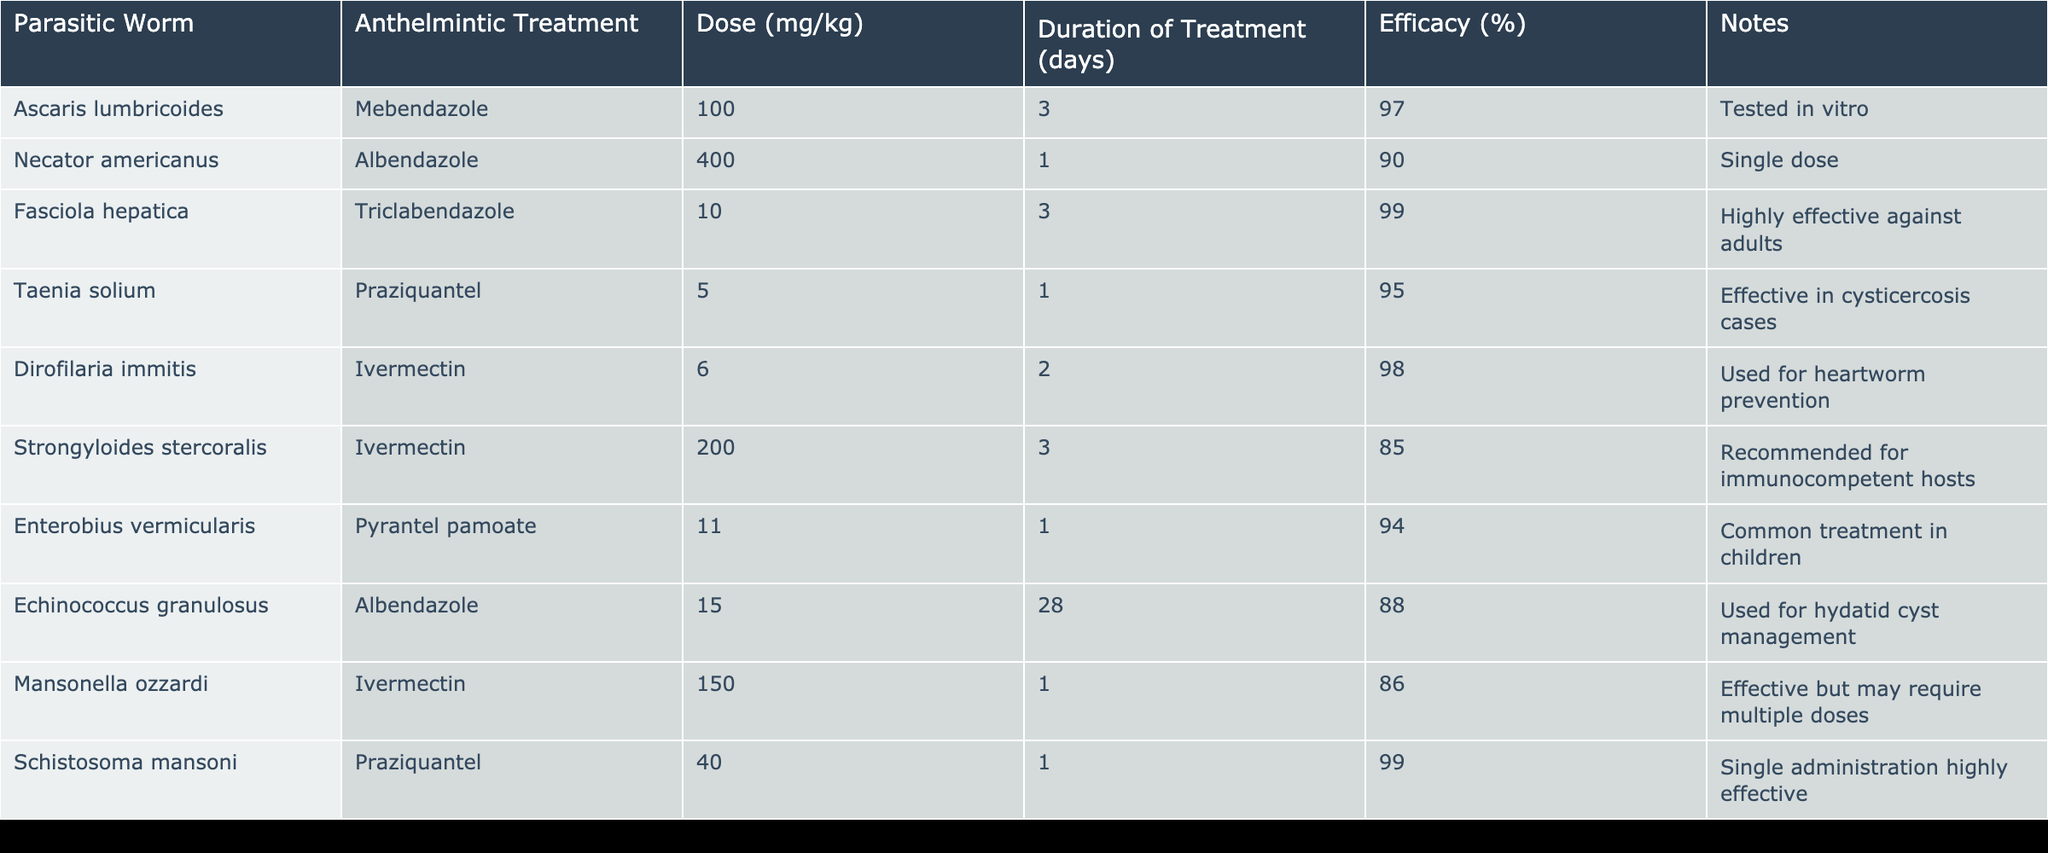What is the efficacy of Mebendazole in treating Ascaris lumbricoides? The table lists the efficacy of Mebendazole for Ascaris lumbricoides as 97%. This information is directly taken from the corresponding row in the table.
Answer: 97% Which anthelmintic treatment has the highest efficacy? Looking through the efficacy percentages in the table, Triclabendazole for Fasciola hepatica shows the highest value at 99%. Thus, it can be concluded that this treatment is the most effective among those listed.
Answer: 99% How many days was Ivermectin administered to treat Strongyloides stercoralis? The table indicates that Ivermectin was administered for 3 days to treat Strongyloides stercoralis, as found in the relevant row under the Duration of Treatment column.
Answer: 3 days Is Pyrantel pamoate effective against Enterobius vermicularis? According to the table, Pyrantel pamoate has an efficacy of 94%, which indicates that it is effective against Enterobius vermicularis.
Answer: Yes What is the average efficacy of the anthelmintic treatments listed in the table? First, I need to sum the efficacy percentages of all treatments: 97 + 90 + 99 + 95 + 98 + 85 + 94 + 88 + 86 + 99 = 921. There are 10 treatments, so the average efficacy is 921 ÷ 10 = 92.1%.
Answer: 92.1% Which two treatments have an efficacy of at least 95%? By examining the efficacy column, I note that Mebendazole (97%) and Triclabendazole (99%) both meet the criterion of having at least 95% efficacy. Therefore, those two treatments are the answer to the question.
Answer: Mebendazole and Triclabendazole What is the dose of Albendazole used for treating Echinococcus granulosus? The table shows that the dose of Albendazole for Echinococcus granulosus is 15 mg/kg, as found in the respective entry in the Dose column.
Answer: 15 mg/kg Is there any treatment that has a duration of 1 day? Yes, the table indicates that both Albendazole (for Necator americanus) and Praziquantel (for Schistosoma mansoni) have a duration of treatment of 1 day, confirming that treatments with this duration do exist in the provided data.
Answer: Yes Which treatment is used for heartworm prevention? The table specifies that Ivermectin, with a dose of 6 mg/kg, is used for heartworm prevention. This information can be directly located under the relevant row.
Answer: Ivermectin 